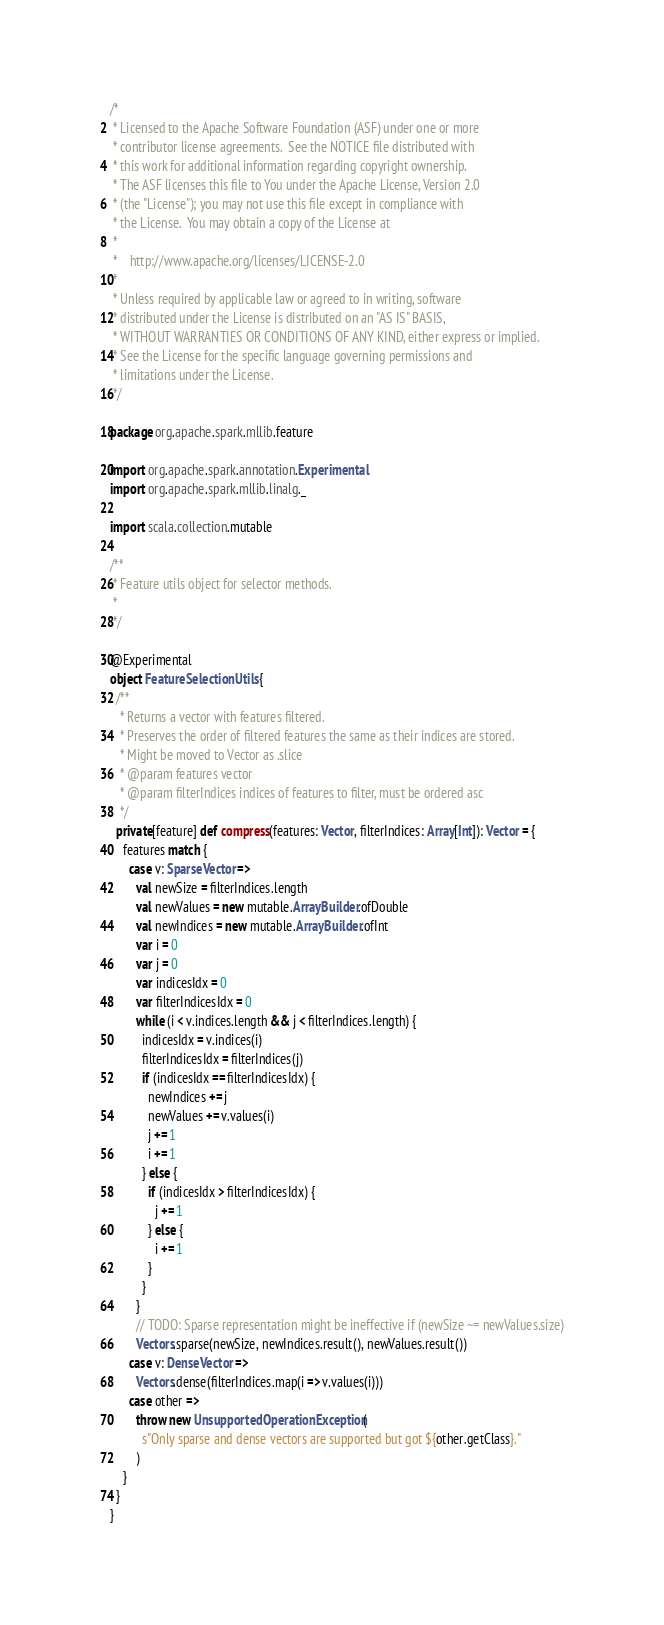<code> <loc_0><loc_0><loc_500><loc_500><_Scala_>/*
 * Licensed to the Apache Software Foundation (ASF) under one or more
 * contributor license agreements.  See the NOTICE file distributed with
 * this work for additional information regarding copyright ownership.
 * The ASF licenses this file to You under the Apache License, Version 2.0
 * (the "License"); you may not use this file except in compliance with
 * the License.  You may obtain a copy of the License at
 *
 *    http://www.apache.org/licenses/LICENSE-2.0
 *
 * Unless required by applicable law or agreed to in writing, software
 * distributed under the License is distributed on an "AS IS" BASIS,
 * WITHOUT WARRANTIES OR CONDITIONS OF ANY KIND, either express or implied.
 * See the License for the specific language governing permissions and
 * limitations under the License.
 */

package org.apache.spark.mllib.feature

import org.apache.spark.annotation.Experimental
import org.apache.spark.mllib.linalg._

import scala.collection.mutable

/**
 * Feature utils object for selector methods.
 *
 */

@Experimental
object FeatureSelectionUtils {
  /**
   * Returns a vector with features filtered.
   * Preserves the order of filtered features the same as their indices are stored.
   * Might be moved to Vector as .slice
   * @param features vector
   * @param filterIndices indices of features to filter, must be ordered asc
   */
  private[feature] def compress(features: Vector, filterIndices: Array[Int]): Vector = {
    features match {
      case v: SparseVector =>
        val newSize = filterIndices.length
        val newValues = new mutable.ArrayBuilder.ofDouble
        val newIndices = new mutable.ArrayBuilder.ofInt
        var i = 0
        var j = 0
        var indicesIdx = 0
        var filterIndicesIdx = 0
        while (i < v.indices.length && j < filterIndices.length) {
          indicesIdx = v.indices(i)
          filterIndicesIdx = filterIndices(j)
          if (indicesIdx == filterIndicesIdx) {
            newIndices += j
            newValues += v.values(i)
            j += 1
            i += 1
          } else {
            if (indicesIdx > filterIndicesIdx) {
              j += 1
            } else {
              i += 1
            }
          }
        }
        // TODO: Sparse representation might be ineffective if (newSize ~= newValues.size)
        Vectors.sparse(newSize, newIndices.result(), newValues.result())
      case v: DenseVector =>
        Vectors.dense(filterIndices.map(i => v.values(i)))
      case other =>
        throw new UnsupportedOperationException(
          s"Only sparse and dense vectors are supported but got ${other.getClass}."
        )
    }
  }
}
</code> 